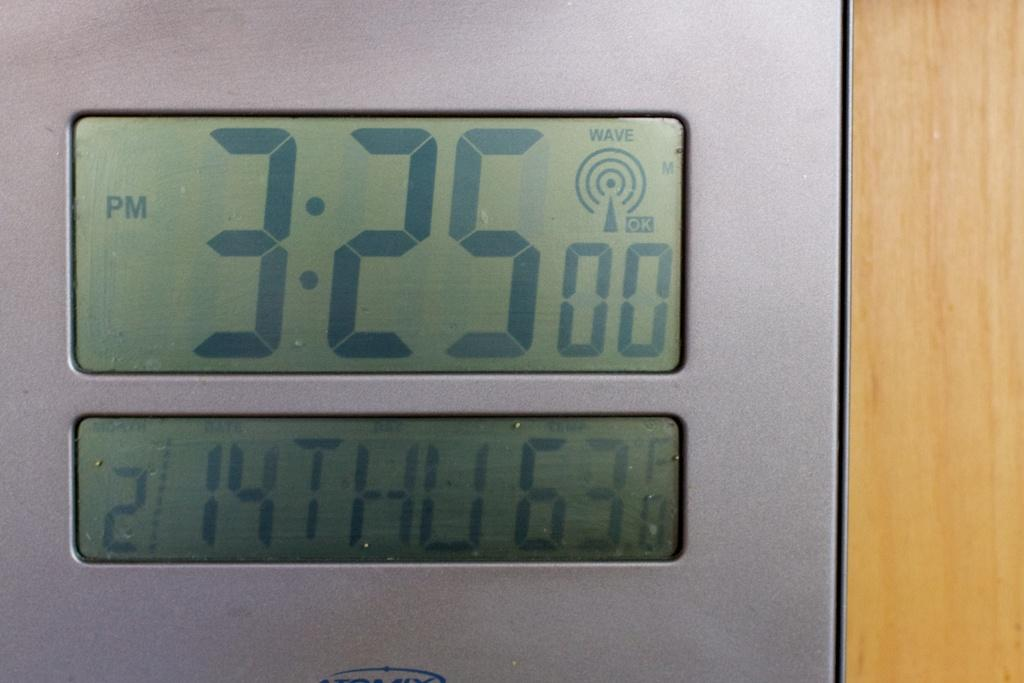<image>
Give a short and clear explanation of the subsequent image. A digital clock that reads 3:25 pm Thursday. 